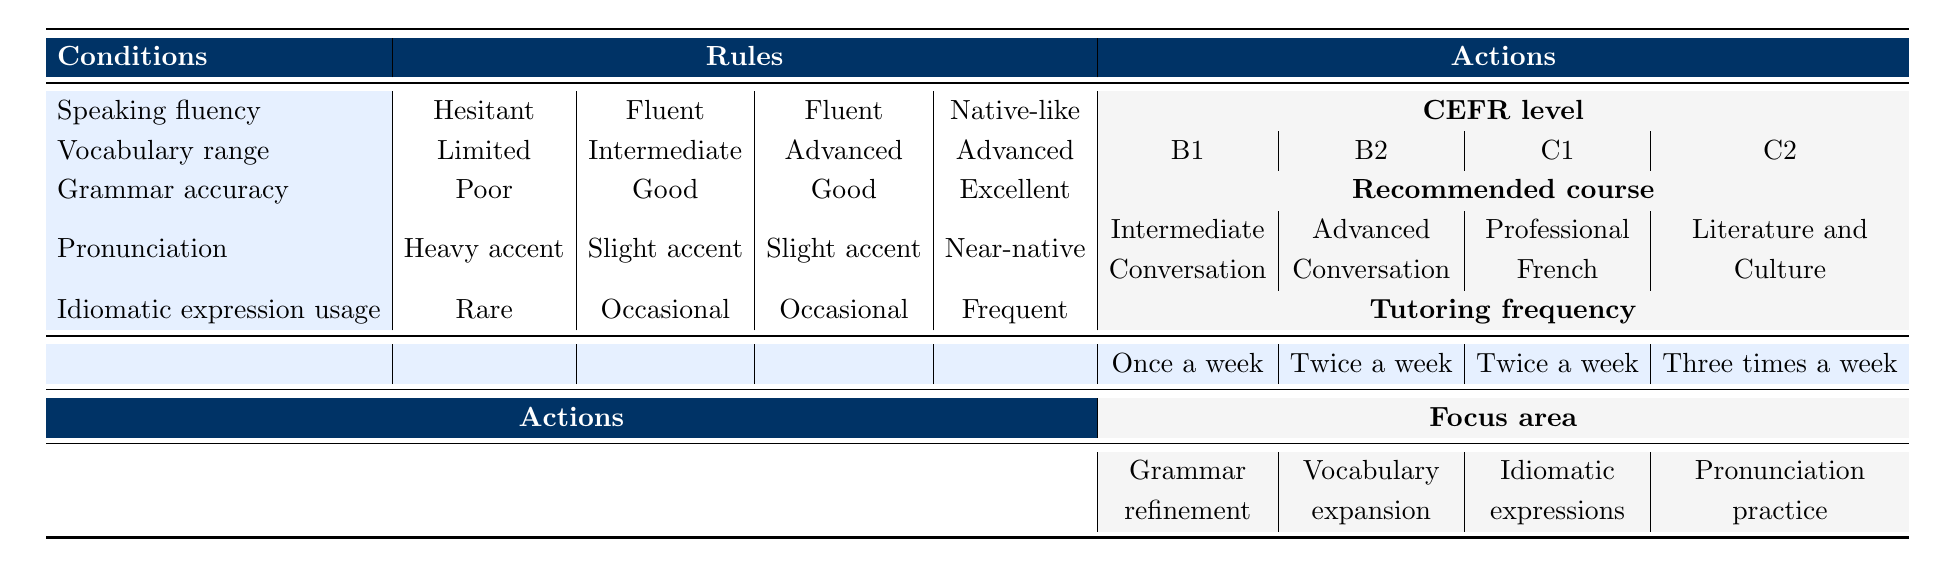What is the CEFR level for someone who is hesitant, has limited vocabulary, poor grammar, a heavy accent, and rarely uses idiomatic expressions? According to the first rule in the table, these conditions correspond to a CEFR level of B1.
Answer: B1 What is the recommended course for a fluent speaker with intermediate vocabulary, good grammar, a slight accent, and occasional idiomatic expression usage? Referring to the second rule, this profile is associated with the recommended course of Advanced Conversation.
Answer: Advanced Conversation What is the tutoring frequency for someone who is native-like, has an advanced vocabulary, excellent grammar, near-native pronunciation, and frequently uses idiomatic expressions? From the fourth rule, it states that this learner should have tutoring frequency of once a week.
Answer: Once a week Is there a recommended course for someone who is fluent with an advanced vocabulary, good grammar, a slight accent, and occasionally uses idiomatic expressions? The rule specifies that individuals with these characteristics are advised to take a Professional French course.
Answer: Yes What focus area is suggested for a learner at CEFR level C2? By looking at the conditions leading to a CEFR level of C2, which include native-like speaking, advanced vocabulary, excellent grammar, near-native pronunciation, and frequent idiomatic expression usage, the focus area is Pronunciation practice.
Answer: Pronunciation practice What is the percentage of learners recommended for 'Intermediate Conversation'? There is one instance in the table where 'Intermediate Conversation' is advised, which is among four total recommendations (B1, B2, C1, C2). Thus, the percentage is (1/4)*100 = 25%.
Answer: 25% If a student is fluent but has a heavy accent, what CEFR level can they achieve with good grammar and an intermediate vocabulary? The conditions do not match any specific recommendation because the needed combination is not present. The closest might be B2 but would generally not categorize without clear references.
Answer: No clear level What are the conditions for a learner recommended to have three tutoring sessions a week? In the table, only the profile of native-like, advanced, excellent, near-native, and frequent idiomatic expression usage indicates this with the corresponding action for three times a week.
Answer: Three times a week Is it true that anyone with poor grammar is likely to be categorized at level C2? According to the rules, individuals with poor grammar are assigned to the B1 level, not C2, making this statement false.
Answer: No 